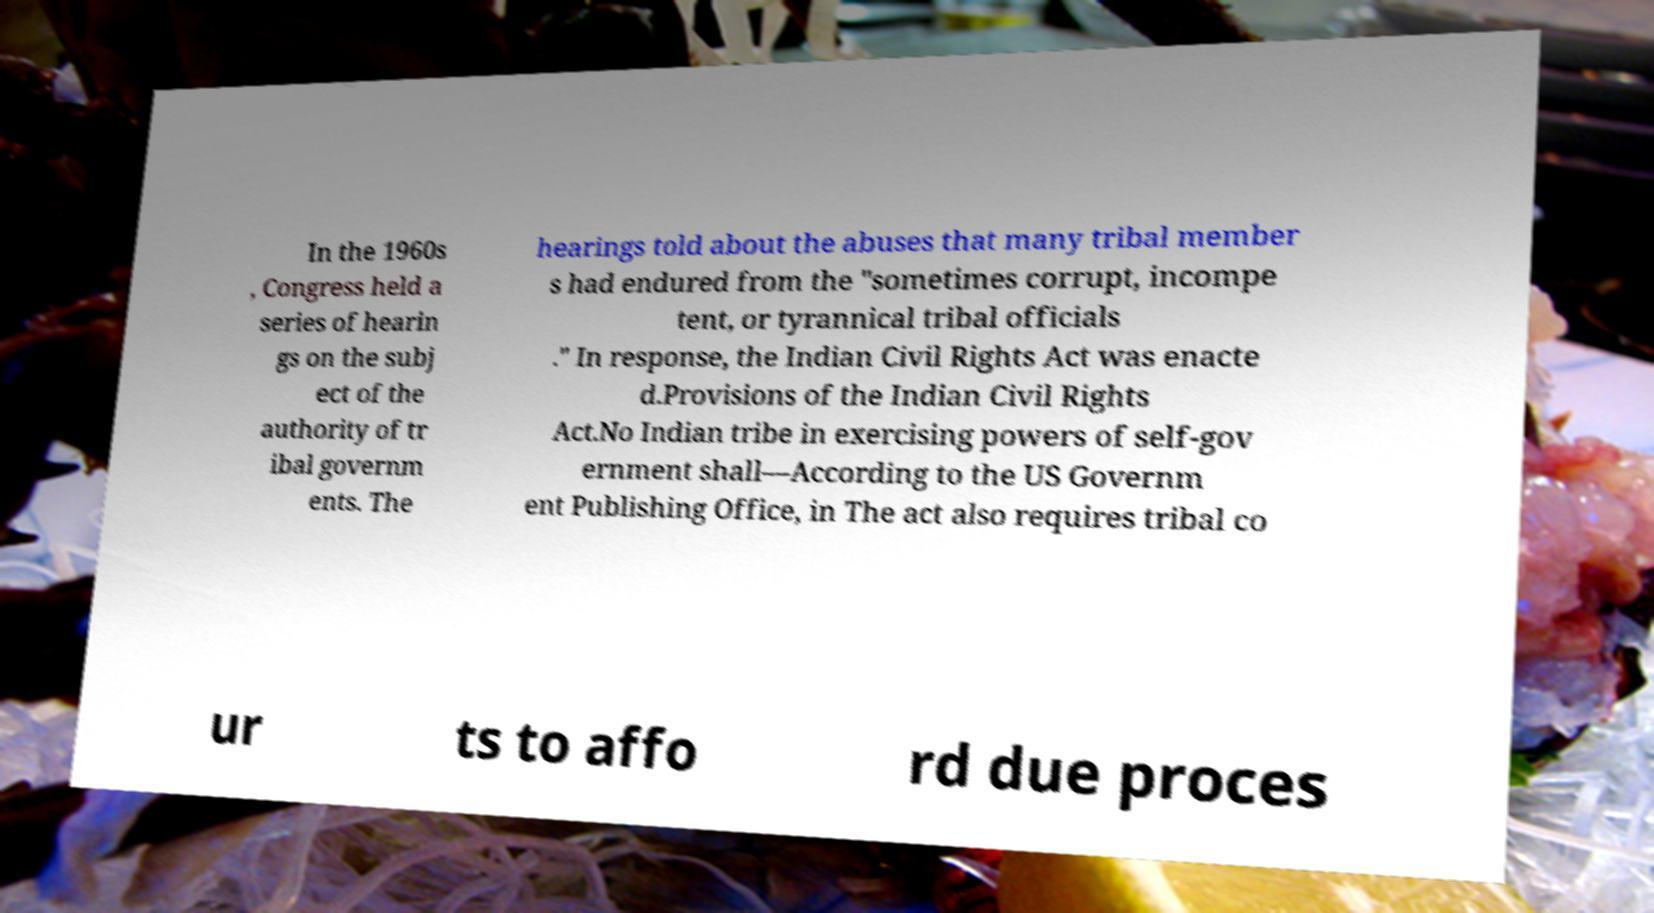What messages or text are displayed in this image? I need them in a readable, typed format. In the 1960s , Congress held a series of hearin gs on the subj ect of the authority of tr ibal governm ents. The hearings told about the abuses that many tribal member s had endured from the "sometimes corrupt, incompe tent, or tyrannical tribal officials ." In response, the Indian Civil Rights Act was enacte d.Provisions of the Indian Civil Rights Act.No Indian tribe in exercising powers of self-gov ernment shall—According to the US Governm ent Publishing Office, in The act also requires tribal co ur ts to affo rd due proces 